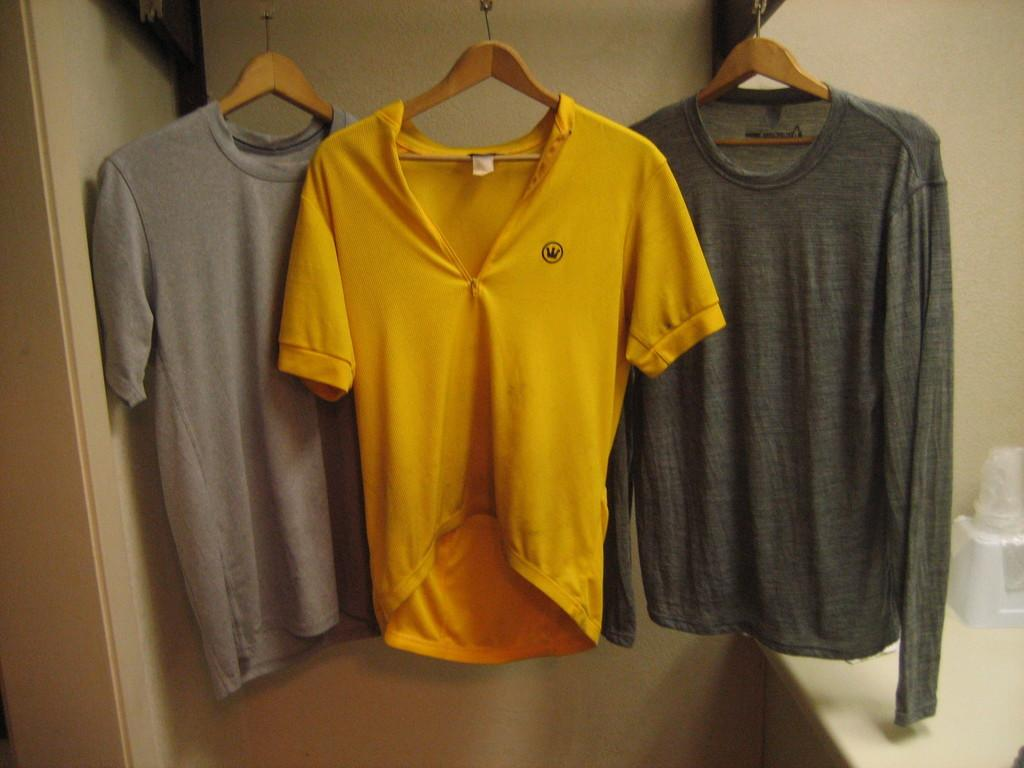What is the main subject of the image? The main subject of the image is clothes hanging on hangers in the center of the image. What can be seen in the background of the image? There is a wall and an object on a stand in the background of the image. What sound can be heard coming from the clothes in the image? There is no sound coming from the clothes in the image, as clothes do not produce sound. 